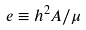<formula> <loc_0><loc_0><loc_500><loc_500>e \equiv h ^ { 2 } A / \mu</formula> 